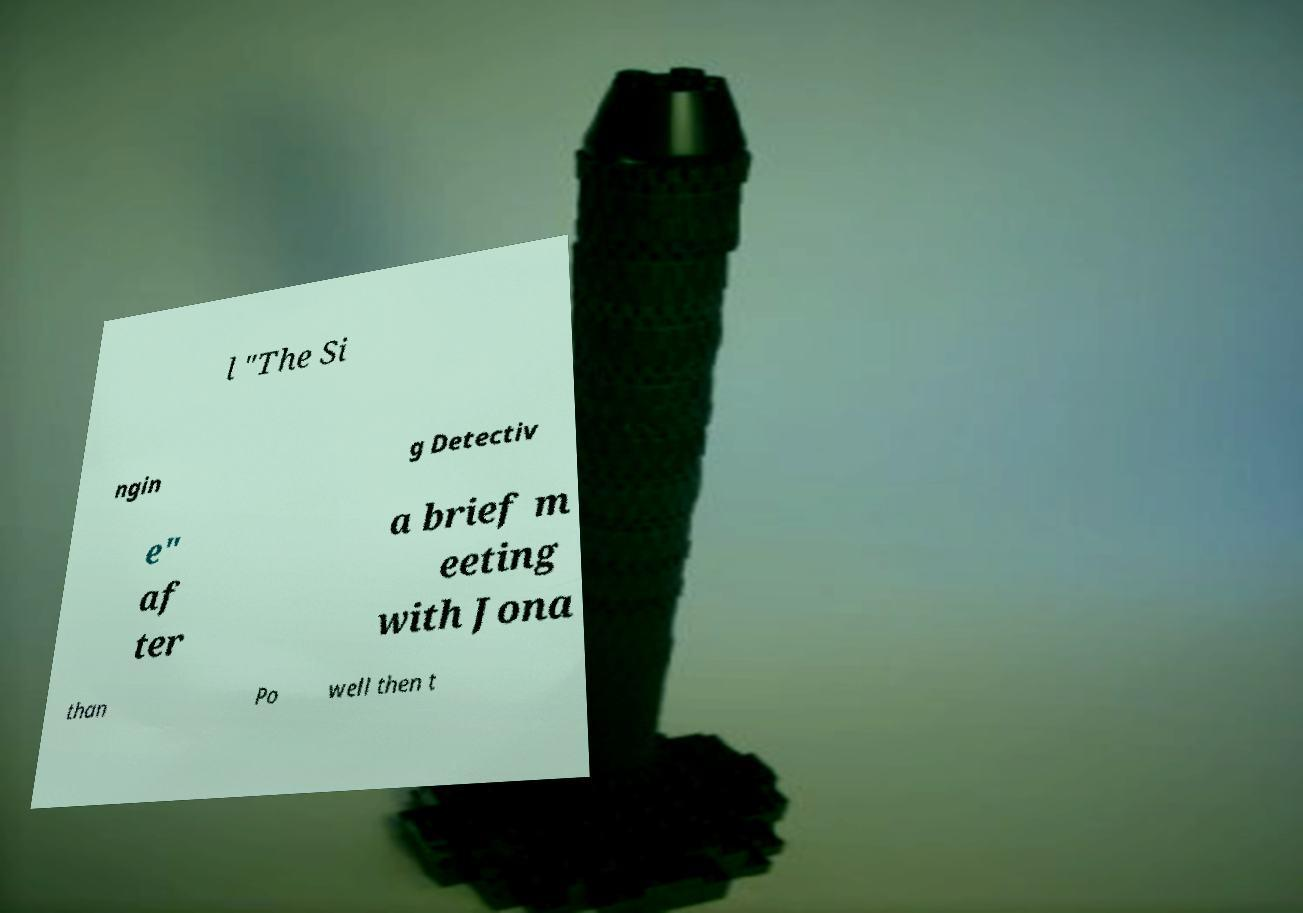I need the written content from this picture converted into text. Can you do that? l "The Si ngin g Detectiv e" af ter a brief m eeting with Jona than Po well then t 